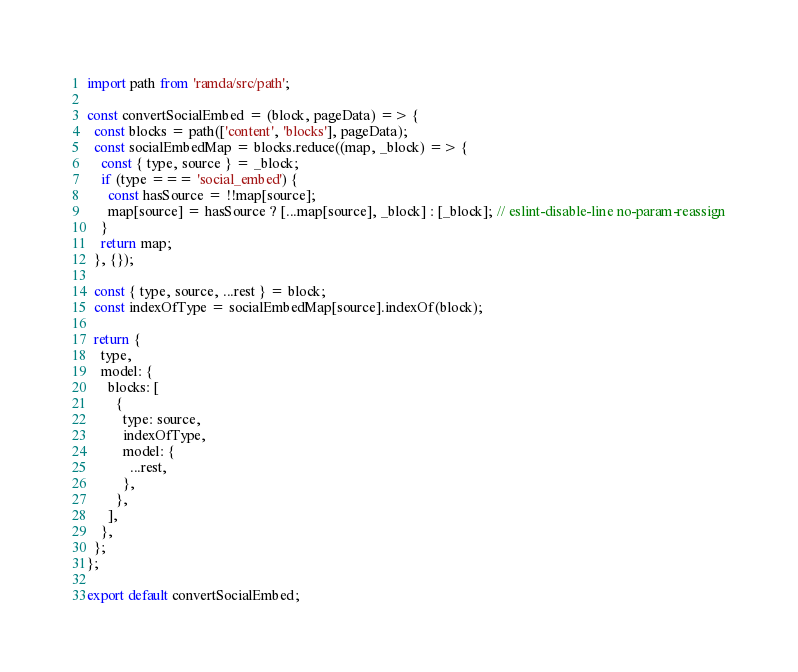Convert code to text. <code><loc_0><loc_0><loc_500><loc_500><_JavaScript_>import path from 'ramda/src/path';

const convertSocialEmbed = (block, pageData) => {
  const blocks = path(['content', 'blocks'], pageData);
  const socialEmbedMap = blocks.reduce((map, _block) => {
    const { type, source } = _block;
    if (type === 'social_embed') {
      const hasSource = !!map[source];
      map[source] = hasSource ? [...map[source], _block] : [_block]; // eslint-disable-line no-param-reassign
    }
    return map;
  }, {});

  const { type, source, ...rest } = block;
  const indexOfType = socialEmbedMap[source].indexOf(block);

  return {
    type,
    model: {
      blocks: [
        {
          type: source,
          indexOfType,
          model: {
            ...rest,
          },
        },
      ],
    },
  };
};

export default convertSocialEmbed;
</code> 